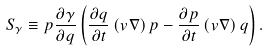Convert formula to latex. <formula><loc_0><loc_0><loc_500><loc_500>S _ { \gamma } \equiv p \frac { \partial \gamma } { \partial q } \left ( \frac { \partial q } { \partial t } \left ( { v } { \nabla } \right ) p - \frac { \partial p } { \partial t } \left ( { v } { \nabla } \right ) q \right ) .</formula> 